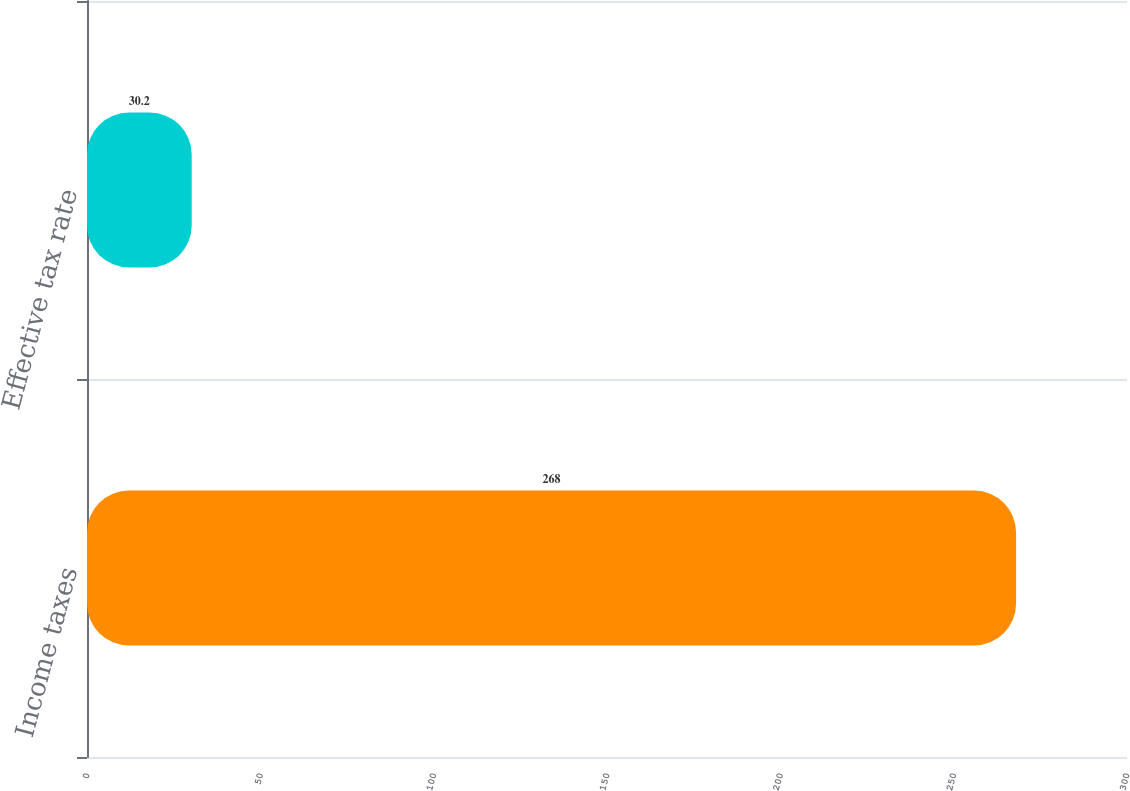Convert chart to OTSL. <chart><loc_0><loc_0><loc_500><loc_500><bar_chart><fcel>Income taxes<fcel>Effective tax rate<nl><fcel>268<fcel>30.2<nl></chart> 